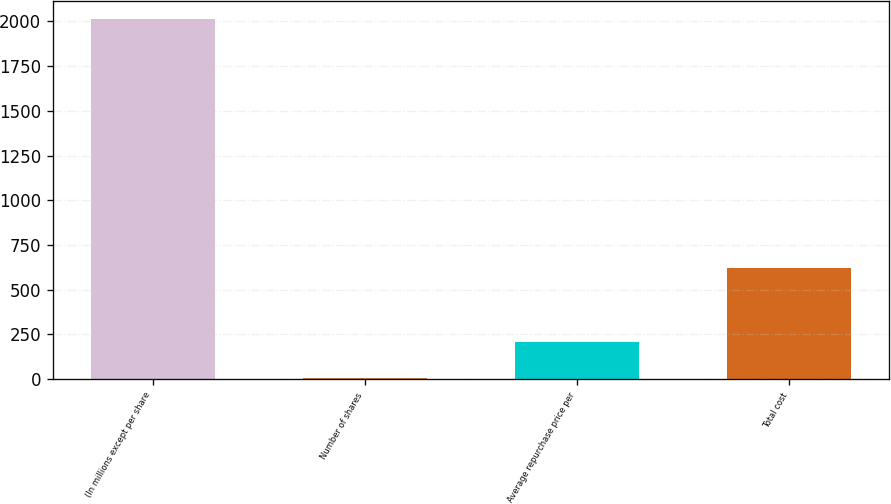<chart> <loc_0><loc_0><loc_500><loc_500><bar_chart><fcel>(In millions except per share<fcel>Number of shares<fcel>Average repurchase price per<fcel>Total cost<nl><fcel>2014<fcel>7.8<fcel>208.42<fcel>624<nl></chart> 